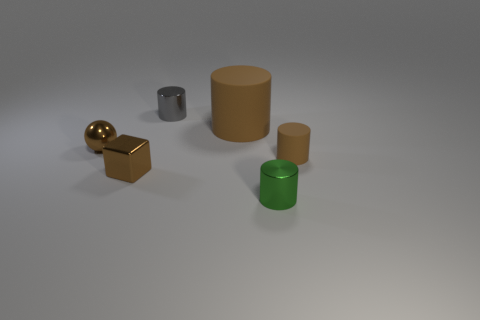Subtract all tiny gray shiny cylinders. How many cylinders are left? 3 Subtract all green cylinders. How many cylinders are left? 3 Subtract all red spheres. How many brown cylinders are left? 2 Add 1 big objects. How many objects exist? 7 Subtract 1 cylinders. How many cylinders are left? 3 Add 6 small blue metallic cubes. How many small blue metallic cubes exist? 6 Subtract 0 gray cubes. How many objects are left? 6 Subtract all spheres. How many objects are left? 5 Subtract all brown cylinders. Subtract all brown balls. How many cylinders are left? 2 Subtract all tiny blocks. Subtract all cubes. How many objects are left? 4 